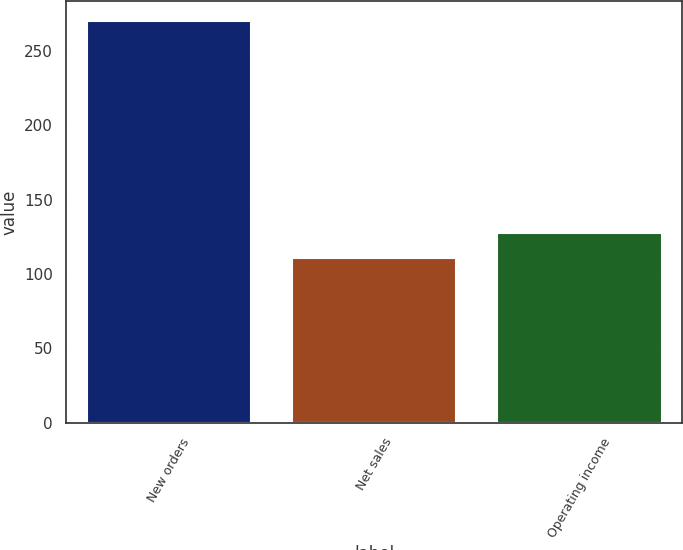Convert chart. <chart><loc_0><loc_0><loc_500><loc_500><bar_chart><fcel>New orders<fcel>Net sales<fcel>Operating income<nl><fcel>270<fcel>111<fcel>128<nl></chart> 